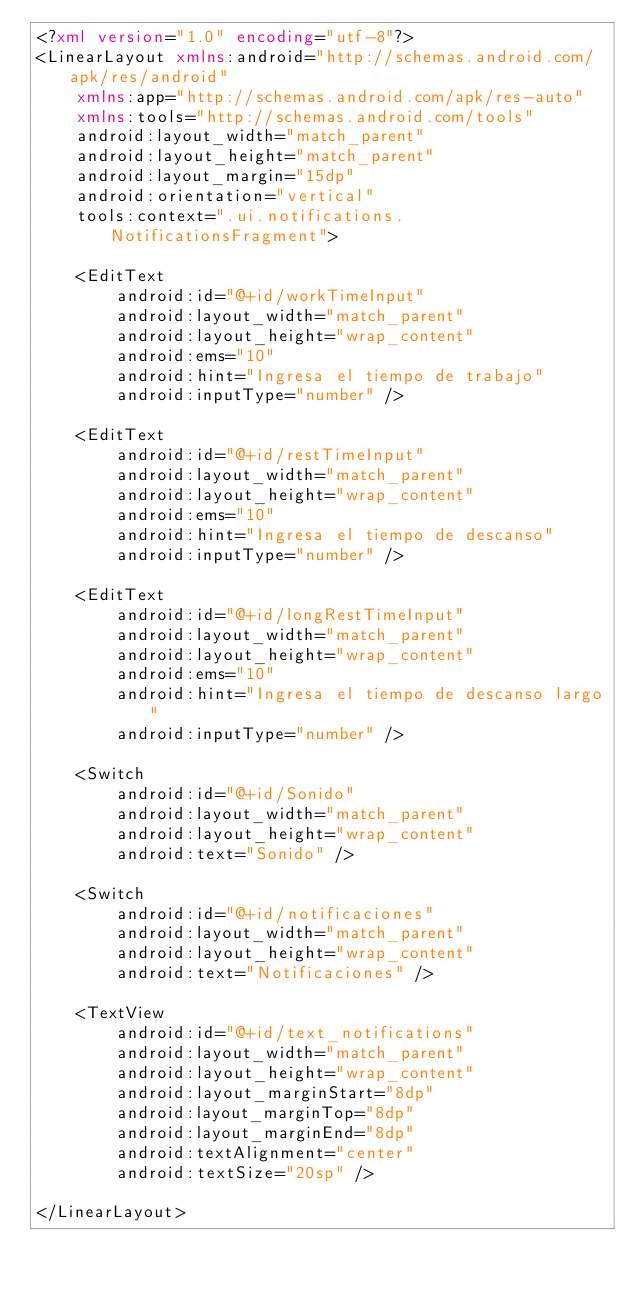<code> <loc_0><loc_0><loc_500><loc_500><_XML_><?xml version="1.0" encoding="utf-8"?>
<LinearLayout xmlns:android="http://schemas.android.com/apk/res/android"
    xmlns:app="http://schemas.android.com/apk/res-auto"
    xmlns:tools="http://schemas.android.com/tools"
    android:layout_width="match_parent"
    android:layout_height="match_parent"
    android:layout_margin="15dp"
    android:orientation="vertical"
    tools:context=".ui.notifications.NotificationsFragment">

    <EditText
        android:id="@+id/workTimeInput"
        android:layout_width="match_parent"
        android:layout_height="wrap_content"
        android:ems="10"
        android:hint="Ingresa el tiempo de trabajo"
        android:inputType="number" />

    <EditText
        android:id="@+id/restTimeInput"
        android:layout_width="match_parent"
        android:layout_height="wrap_content"
        android:ems="10"
        android:hint="Ingresa el tiempo de descanso"
        android:inputType="number" />

    <EditText
        android:id="@+id/longRestTimeInput"
        android:layout_width="match_parent"
        android:layout_height="wrap_content"
        android:ems="10"
        android:hint="Ingresa el tiempo de descanso largo"
        android:inputType="number" />

    <Switch
        android:id="@+id/Sonido"
        android:layout_width="match_parent"
        android:layout_height="wrap_content"
        android:text="Sonido" />

    <Switch
        android:id="@+id/notificaciones"
        android:layout_width="match_parent"
        android:layout_height="wrap_content"
        android:text="Notificaciones" />

    <TextView
        android:id="@+id/text_notifications"
        android:layout_width="match_parent"
        android:layout_height="wrap_content"
        android:layout_marginStart="8dp"
        android:layout_marginTop="8dp"
        android:layout_marginEnd="8dp"
        android:textAlignment="center"
        android:textSize="20sp" />

</LinearLayout></code> 